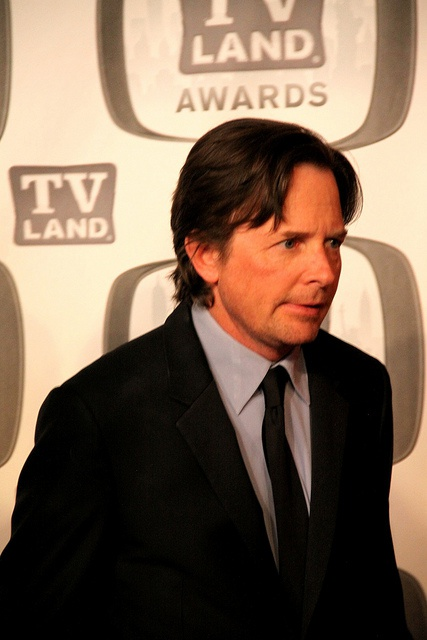Describe the objects in this image and their specific colors. I can see people in olive, black, red, maroon, and salmon tones and tie in olive, black, brown, and maroon tones in this image. 